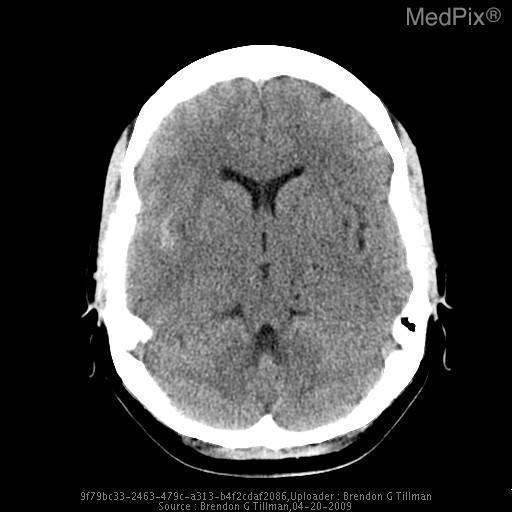Is there grey-white matter differentiation?
Concise answer only. Yes. What brain territory is the hemorrhage located?
Keep it brief. Right sylvian fissure. Which fissure is the hemorrhage located?
Give a very brief answer. Right sylvian fissure. What category is the hemmorhage?
Give a very brief answer. Subarachnoid. What type of hemorrhage is shown?
Quick response, please. Subarachnoid. Does this ct use iv contrast material?
Give a very brief answer. No. Is this a contrast or non contrast ct?
Answer briefly. Non-contrast. 